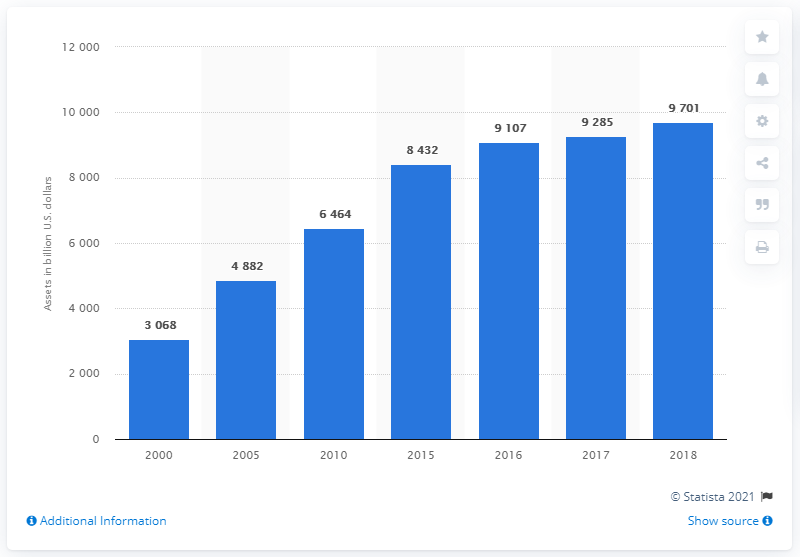Identify some key points in this picture. In 2018, the value of assets held by U.S. households and non-profit organizations in time and savings deposits was approximately $9,701. 